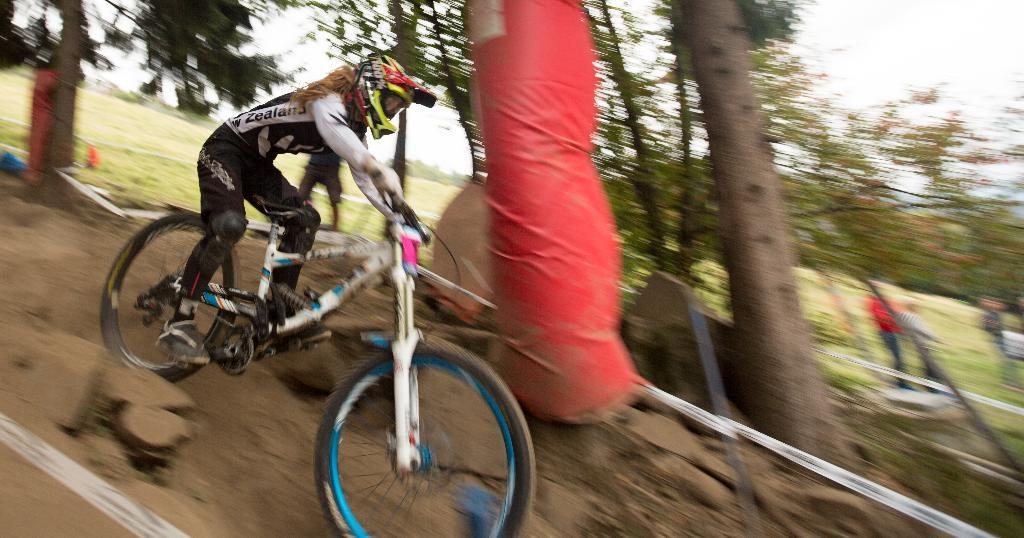Who is the main subject in the image? There is a woman in the image. What protective gear is the woman wearing? The woman is wearing a helmet. What type of footwear is the woman wearing? The woman is wearing shoes. What is the woman doing in the image? The woman is riding a bicycle. What is the position of the bicycle in the image? The bicycle is on the ground. What type of vegetation can be seen in the image? There are trees in the image. Are there any other people present in the image? Yes, there are people standing in the image. What can be seen in the background of the image? The sky is visible in the background of the image. What type of joke is being told by the woman on the bicycle in the image? There is no indication in the image that the woman is telling a joke; she is simply riding a bicycle. 